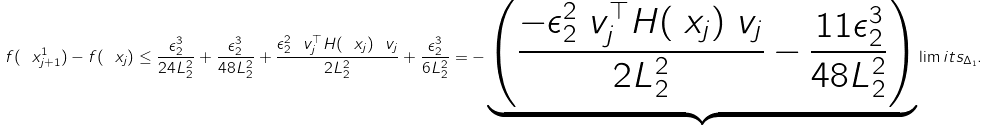Convert formula to latex. <formula><loc_0><loc_0><loc_500><loc_500>f ( \ x ^ { 1 } _ { j + 1 } ) - f ( \ x _ { j } ) \leq \frac { \epsilon _ { 2 } ^ { 3 } } { 2 4 L _ { 2 } ^ { 2 } } + \frac { \epsilon _ { 2 } ^ { 3 } } { 4 8 L _ { 2 } ^ { 2 } } + \frac { \epsilon _ { 2 } ^ { 2 } \ v _ { j } ^ { \top } H ( \ x _ { j } ) \ v _ { j } } { 2 L _ { 2 } ^ { 2 } } + \frac { \epsilon _ { 2 } ^ { 3 } } { 6 L _ { 2 } ^ { 2 } } = - \underbrace { \left ( \frac { - \epsilon _ { 2 } ^ { 2 } \ v _ { j } ^ { \top } H ( \ x _ { j } ) \ v _ { j } } { 2 L _ { 2 } ^ { 2 } } - \frac { 1 1 \epsilon _ { 2 } ^ { 3 } } { 4 8 L _ { 2 } ^ { 2 } } \right ) } \lim i t s _ { \Delta _ { 1 } } .</formula> 